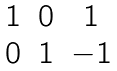Convert formula to latex. <formula><loc_0><loc_0><loc_500><loc_500>\begin{matrix} 1 & 0 & 1 \\ 0 & 1 & - 1 \end{matrix}</formula> 